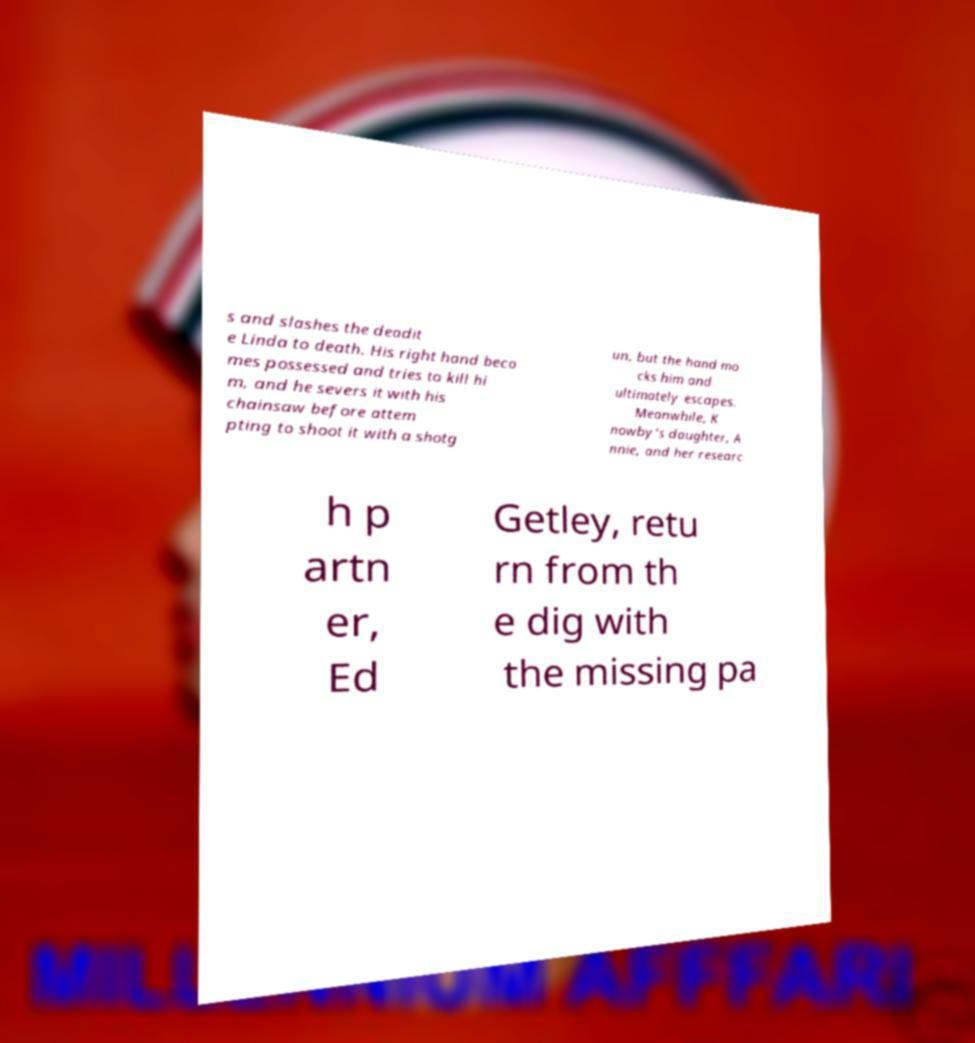For documentation purposes, I need the text within this image transcribed. Could you provide that? s and slashes the deadit e Linda to death. His right hand beco mes possessed and tries to kill hi m, and he severs it with his chainsaw before attem pting to shoot it with a shotg un, but the hand mo cks him and ultimately escapes. Meanwhile, K nowby's daughter, A nnie, and her researc h p artn er, Ed Getley, retu rn from th e dig with the missing pa 